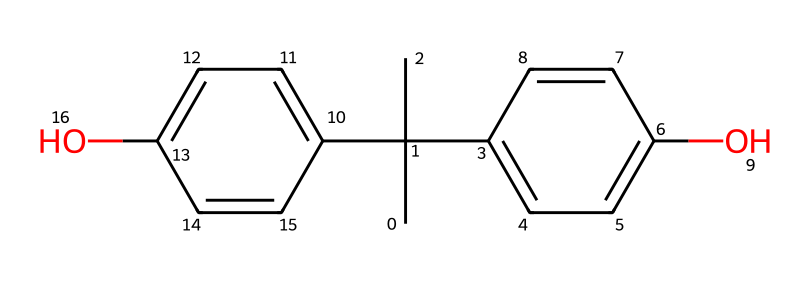What is the primary functional group present in this chemical? The chemical structure contains hydroxyl (-OH) groups, which indicate that it has phenolic functional groups. This can be deduced from the presence of the oxygen atoms connected to carbon rings.
Answer: hydroxyl How many carbon atoms are in bisphenol A? By analyzing the chemical structure and counting each carbon (C) atom visually in the SMILES representation, there are a total of 15 carbon atoms.
Answer: 15 What type of isomerism might be present in bisphenol A? Given the presence of multiple rings and groups in the structure, bisphenol A can exhibit both cis/trans isomerism and potentially positional isomerism due to the various substituents on the rings.
Answer: isomerism Does bisphenol A contain any double bonds? In the chemical structure, double bonds can be identified by looking at the carbon-carbon connections, and it is clear that there are indeed double bonds present in the aromatic rings.
Answer: yes What might be the effect of bisphenol A on human health due to its structure? The structure of bisphenol A suggests potential hormonal activity due to the presence of phenolic groups, which are known for their endocrine-disrupting properties. This relates to how it mimics estrogen in the body, leading to health concerns.
Answer: endocrine disruptor How many hydroxyl groups are present in bisphenol A? By identifying each hydroxyl (-OH) group in the structure, we can quantify them; there are two hydroxyl groups in bisphenol A.
Answer: 2 What forms of bonding are prevalent in bisphenol A? The chemical structure features covalent bonding primarily among carbon, hydrogen, and oxygen atoms, as inferred from connectivity and typical bonding patterns in organic molecules.
Answer: covalent 